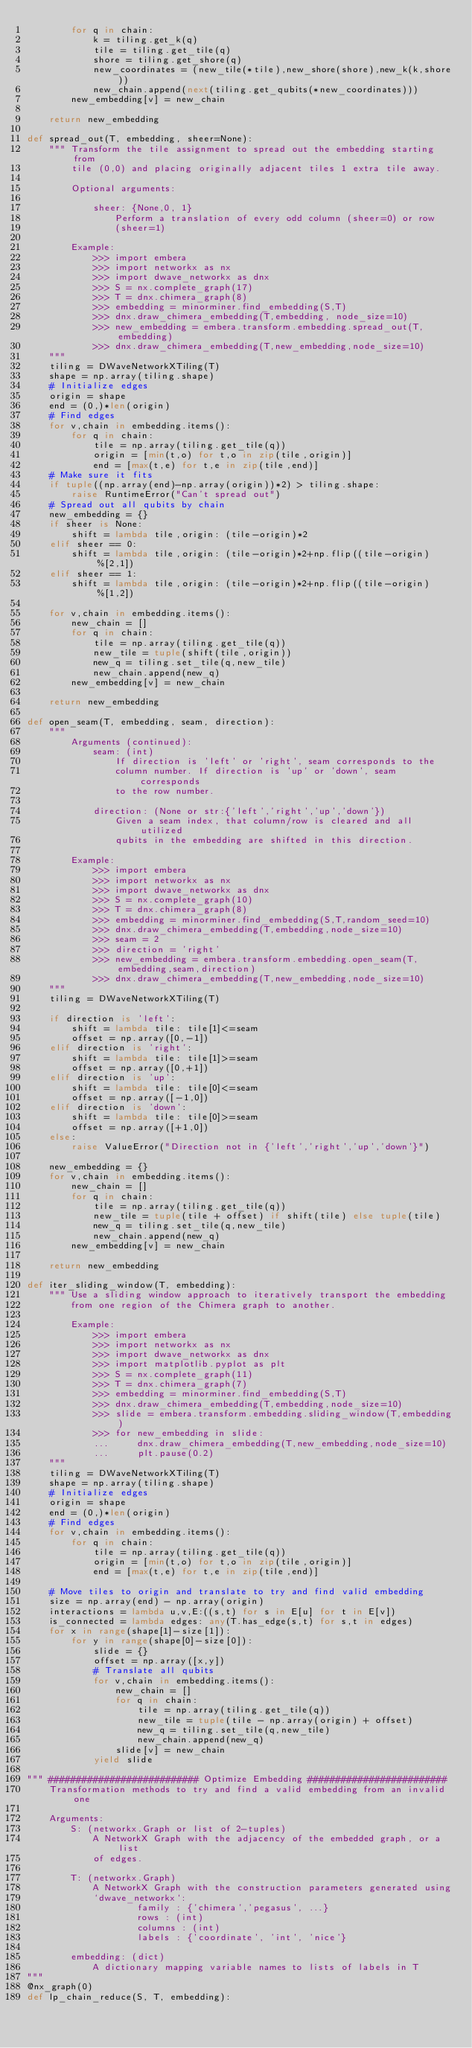Convert code to text. <code><loc_0><loc_0><loc_500><loc_500><_Python_>        for q in chain:
            k = tiling.get_k(q)
            tile = tiling.get_tile(q)
            shore = tiling.get_shore(q)
            new_coordinates = (new_tile(*tile),new_shore(shore),new_k(k,shore))
            new_chain.append(next(tiling.get_qubits(*new_coordinates)))
        new_embedding[v] = new_chain

    return new_embedding

def spread_out(T, embedding, sheer=None):
    """ Transform the tile assignment to spread out the embedding starting from
        tile (0,0) and placing originally adjacent tiles 1 extra tile away.

        Optional arguments:

            sheer: {None,0, 1}
                Perform a translation of every odd column (sheer=0) or row
                (sheer=1)

        Example:
            >>> import embera
            >>> import networkx as nx
            >>> import dwave_networkx as dnx
            >>> S = nx.complete_graph(17)
            >>> T = dnx.chimera_graph(8)
            >>> embedding = minorminer.find_embedding(S,T)
            >>> dnx.draw_chimera_embedding(T,embedding, node_size=10)
            >>> new_embedding = embera.transform.embedding.spread_out(T,embedding)
            >>> dnx.draw_chimera_embedding(T,new_embedding,node_size=10)
    """
    tiling = DWaveNetworkXTiling(T)
    shape = np.array(tiling.shape)
    # Initialize edges
    origin = shape
    end = (0,)*len(origin)
    # Find edges
    for v,chain in embedding.items():
        for q in chain:
            tile = np.array(tiling.get_tile(q))
            origin = [min(t,o) for t,o in zip(tile,origin)]
            end = [max(t,e) for t,e in zip(tile,end)]
    # Make sure it fits
    if tuple((np.array(end)-np.array(origin))*2) > tiling.shape:
        raise RuntimeError("Can't spread out")
    # Spread out all qubits by chain
    new_embedding = {}
    if sheer is None:
        shift = lambda tile,origin: (tile-origin)*2
    elif sheer == 0:
        shift = lambda tile,origin: (tile-origin)*2+np.flip((tile-origin)%[2,1])
    elif sheer == 1:
        shift = lambda tile,origin: (tile-origin)*2+np.flip((tile-origin)%[1,2])

    for v,chain in embedding.items():
        new_chain = []
        for q in chain:
            tile = np.array(tiling.get_tile(q))
            new_tile = tuple(shift(tile,origin))
            new_q = tiling.set_tile(q,new_tile)
            new_chain.append(new_q)
        new_embedding[v] = new_chain

    return new_embedding

def open_seam(T, embedding, seam, direction):
    """
        Arguments (continued):
            seam: (int)
                If direction is 'left' or 'right', seam corresponds to the
                column number. If direction is 'up' or 'down', seam corresponds
                to the row number.

            direction: (None or str:{'left','right','up','down'})
                Given a seam index, that column/row is cleared and all utilized
                qubits in the embedding are shifted in this direction.

        Example:
            >>> import embera
            >>> import networkx as nx
            >>> import dwave_networkx as dnx
            >>> S = nx.complete_graph(10)
            >>> T = dnx.chimera_graph(8)
            >>> embedding = minorminer.find_embedding(S,T,random_seed=10)
            >>> dnx.draw_chimera_embedding(T,embedding,node_size=10)
            >>> seam = 2
            >>> direction = 'right'
            >>> new_embedding = embera.transform.embedding.open_seam(T,embedding,seam,direction)
            >>> dnx.draw_chimera_embedding(T,new_embedding,node_size=10)
    """
    tiling = DWaveNetworkXTiling(T)

    if direction is 'left':
        shift = lambda tile: tile[1]<=seam
        offset = np.array([0,-1])
    elif direction is 'right':
        shift = lambda tile: tile[1]>=seam
        offset = np.array([0,+1])
    elif direction is 'up':
        shift = lambda tile: tile[0]<=seam
        offset = np.array([-1,0])
    elif direction is 'down':
        shift = lambda tile: tile[0]>=seam
        offset = np.array([+1,0])
    else:
        raise ValueError("Direction not in {'left','right','up','down'}")

    new_embedding = {}
    for v,chain in embedding.items():
        new_chain = []
        for q in chain:
            tile = np.array(tiling.get_tile(q))
            new_tile = tuple(tile + offset) if shift(tile) else tuple(tile)
            new_q = tiling.set_tile(q,new_tile)
            new_chain.append(new_q)
        new_embedding[v] = new_chain

    return new_embedding

def iter_sliding_window(T, embedding):
    """ Use a sliding window approach to iteratively transport the embedding
        from one region of the Chimera graph to another.

        Example:
            >>> import embera
            >>> import networkx as nx
            >>> import dwave_networkx as dnx
            >>> import matplotlib.pyplot as plt
            >>> S = nx.complete_graph(11)
            >>> T = dnx.chimera_graph(7)
            >>> embedding = minorminer.find_embedding(S,T)
            >>> dnx.draw_chimera_embedding(T,embedding,node_size=10)
            >>> slide = embera.transform.embedding.sliding_window(T,embedding)
            >>> for new_embedding in slide:
            ...     dnx.draw_chimera_embedding(T,new_embedding,node_size=10)
            ...     plt.pause(0.2)
    """
    tiling = DWaveNetworkXTiling(T)
    shape = np.array(tiling.shape)
    # Initialize edges
    origin = shape
    end = (0,)*len(origin)
    # Find edges
    for v,chain in embedding.items():
        for q in chain:
            tile = np.array(tiling.get_tile(q))
            origin = [min(t,o) for t,o in zip(tile,origin)]
            end = [max(t,e) for t,e in zip(tile,end)]

    # Move tiles to origin and translate to try and find valid embedding
    size = np.array(end) - np.array(origin)
    interactions = lambda u,v,E:((s,t) for s in E[u] for t in E[v])
    is_connected = lambda edges: any(T.has_edge(s,t) for s,t in edges)
    for x in range(shape[1]-size[1]):
        for y in range(shape[0]-size[0]):
            slide = {}
            offset = np.array([x,y])
            # Translate all qubits
            for v,chain in embedding.items():
                new_chain = []
                for q in chain:
                    tile = np.array(tiling.get_tile(q))
                    new_tile = tuple(tile - np.array(origin) + offset)
                    new_q = tiling.set_tile(q,new_tile)
                    new_chain.append(new_q)
                slide[v] = new_chain
            yield slide

""" ########################### Optimize Embedding #########################
    Transformation methods to try and find a valid embedding from an invalid one

    Arguments:
        S: (networkx.Graph or list of 2-tuples)
            A NetworkX Graph with the adjacency of the embedded graph, or a list
            of edges.

        T: (networkx.Graph)
            A NetworkX Graph with the construction parameters generated using
            `dwave_networkx`:
                    family : {'chimera','pegasus', ...}
                    rows : (int)
                    columns : (int)
                    labels : {'coordinate', 'int', 'nice'}

        embedding: (dict)
            A dictionary mapping variable names to lists of labels in T
"""
@nx_graph(0)
def lp_chain_reduce(S, T, embedding):</code> 